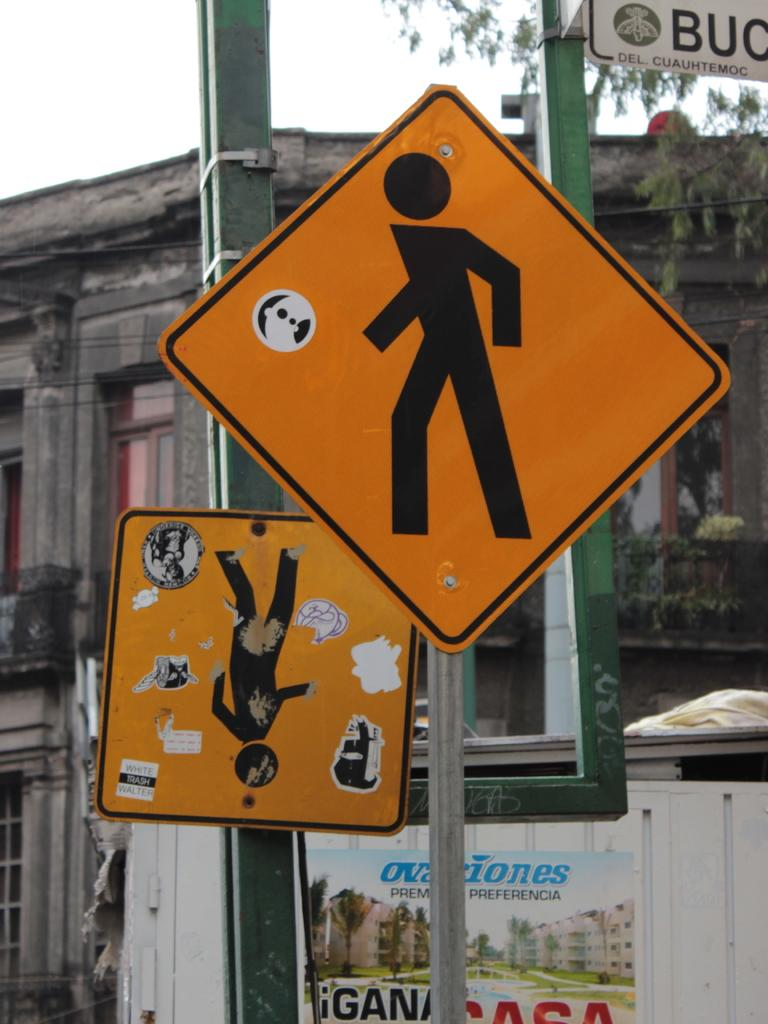<image>
Write a terse but informative summary of the picture. Street signs of walking person with the word white on an upside sign, 